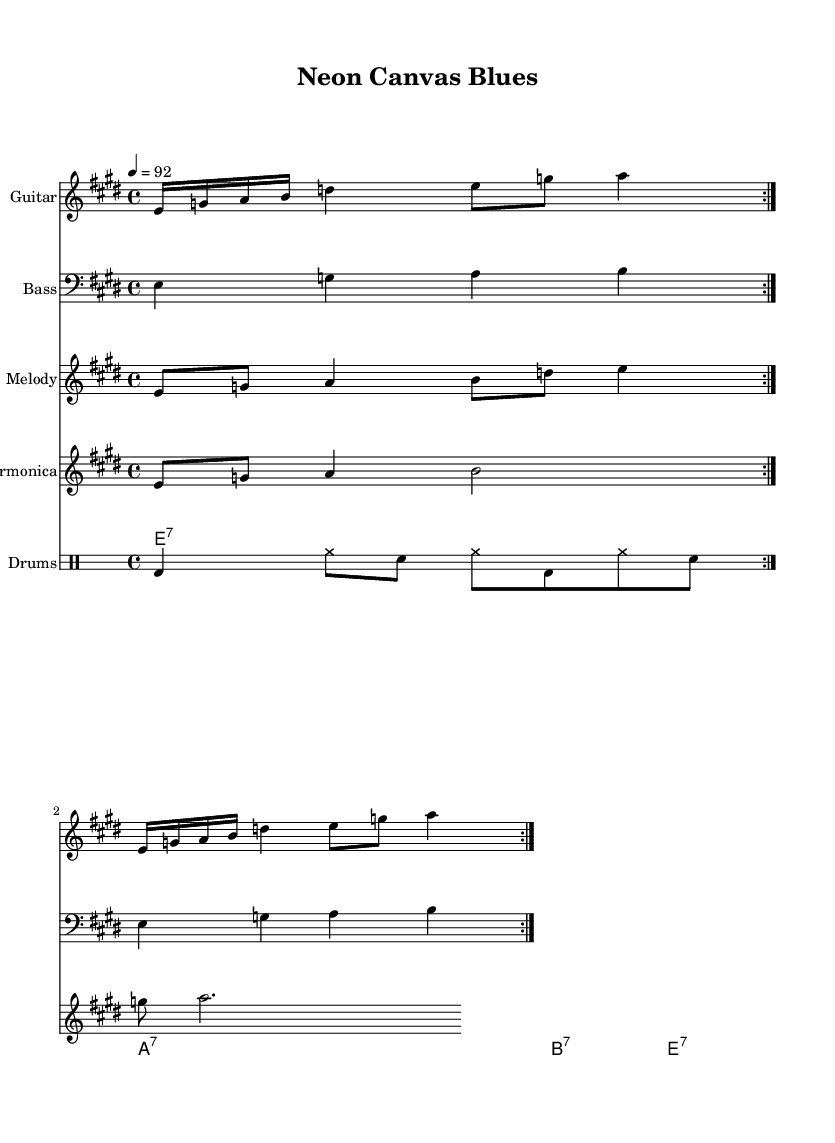What is the key signature of this music? The key signature appears with a sharp (F#), indicating it is E major. The presence of the E major note in the score confirms this.
Answer: E major What is the time signature of this music? The time signature is located at the beginning of the score, appearing as 4/4, meaning there are four beats in each measure and the quarter note gets one beat.
Answer: 4/4 What is the tempo marking for this music? The tempo marking is found at the beginning of the score, which states 4 = 92, meaning the quarter note should be played at a speed of 92 beats per minute.
Answer: 92 How many measures are indicated for the guitar riff? The guitar part shows a repeat sign with the instruction to repeat twice, so it consists of two measures being played in repeats.
Answer: Two What type of line is used for the melody in this music? The melody line is notated in the treble clef, which is standard for higher pitch instruments like the guitar and vocals, and it can be seen at the beginning of the melody staff.
Answer: Treble clef What instruments are present in the score? The score includes four instrumental parts: Guitar, Bass, Melody, and Harmonica, which each are on separate staves, allowing for distinct parts to be performed simultaneously.
Answer: Guitar, Bass, Melody, Harmonica What is the chord progression indicated in the score? The chord progression is mixed within chord names above the staff, which shows E7, A7, B7, and back to E7, indicating a standard 12-bar blues structure.
Answer: E7, A7, B7 